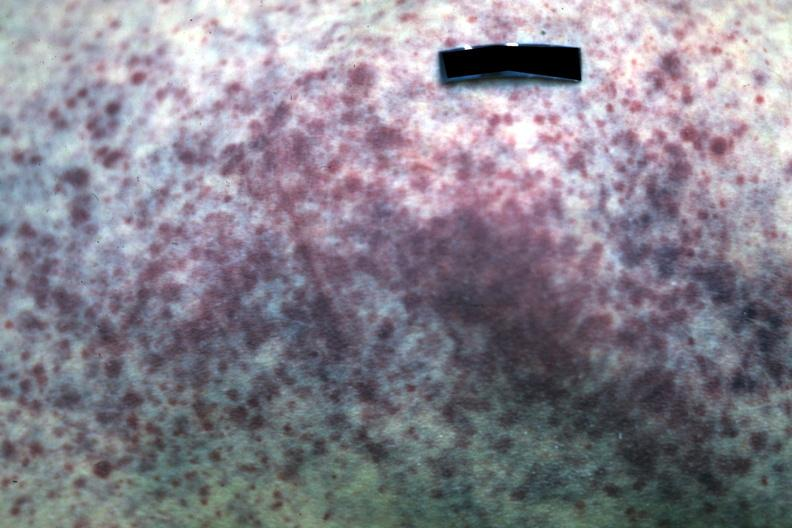where is this?
Answer the question using a single word or phrase. Skin 